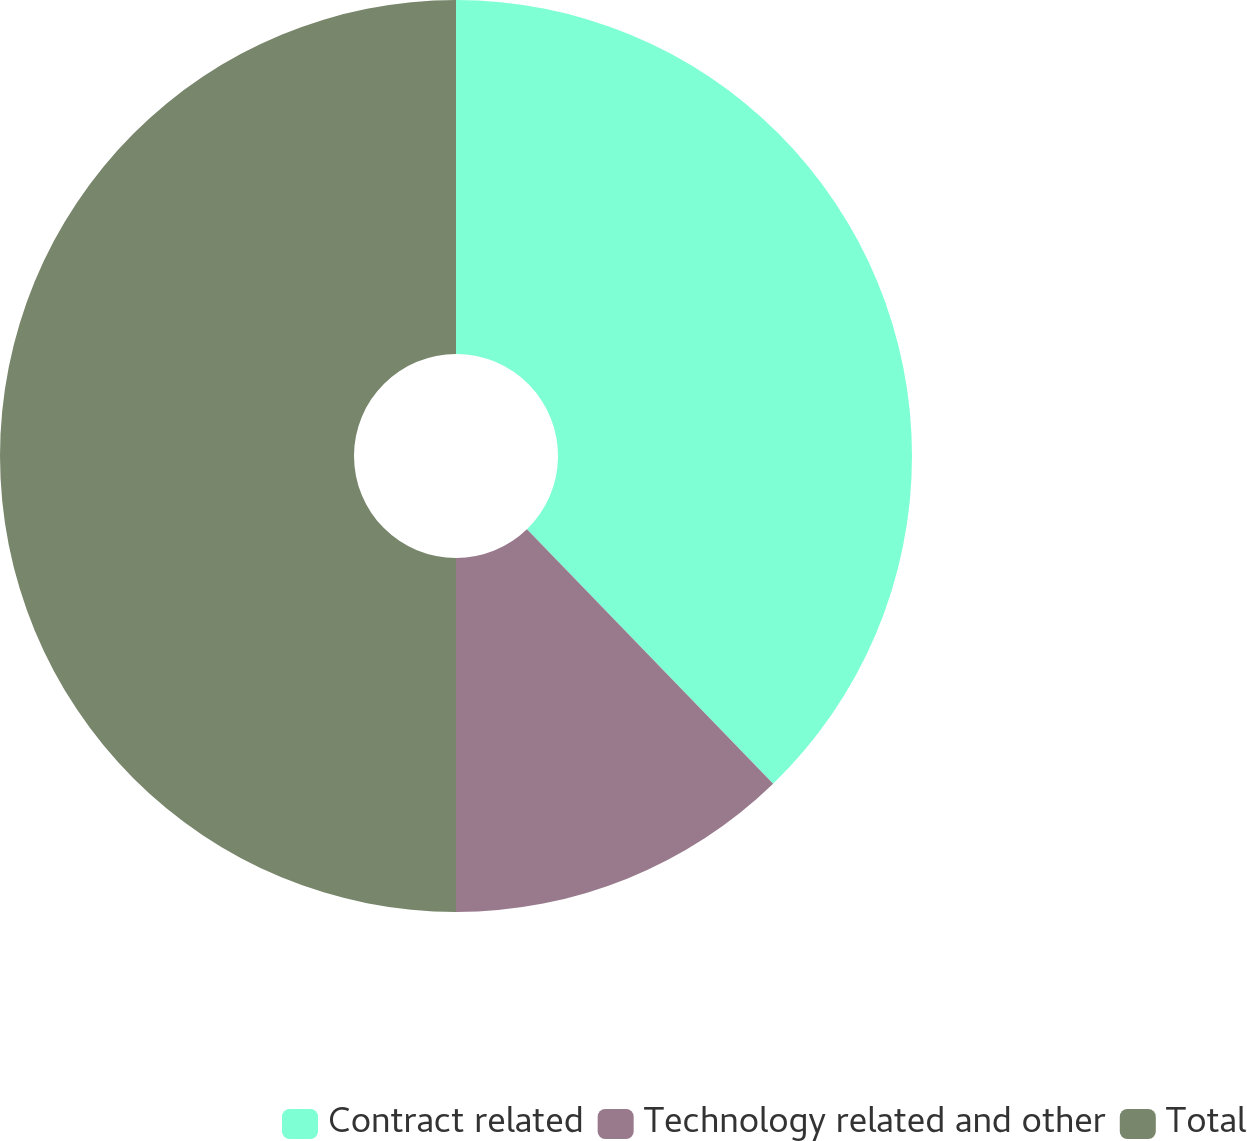Convert chart. <chart><loc_0><loc_0><loc_500><loc_500><pie_chart><fcel>Contract related<fcel>Technology related and other<fcel>Total<nl><fcel>37.76%<fcel>12.24%<fcel>50.0%<nl></chart> 